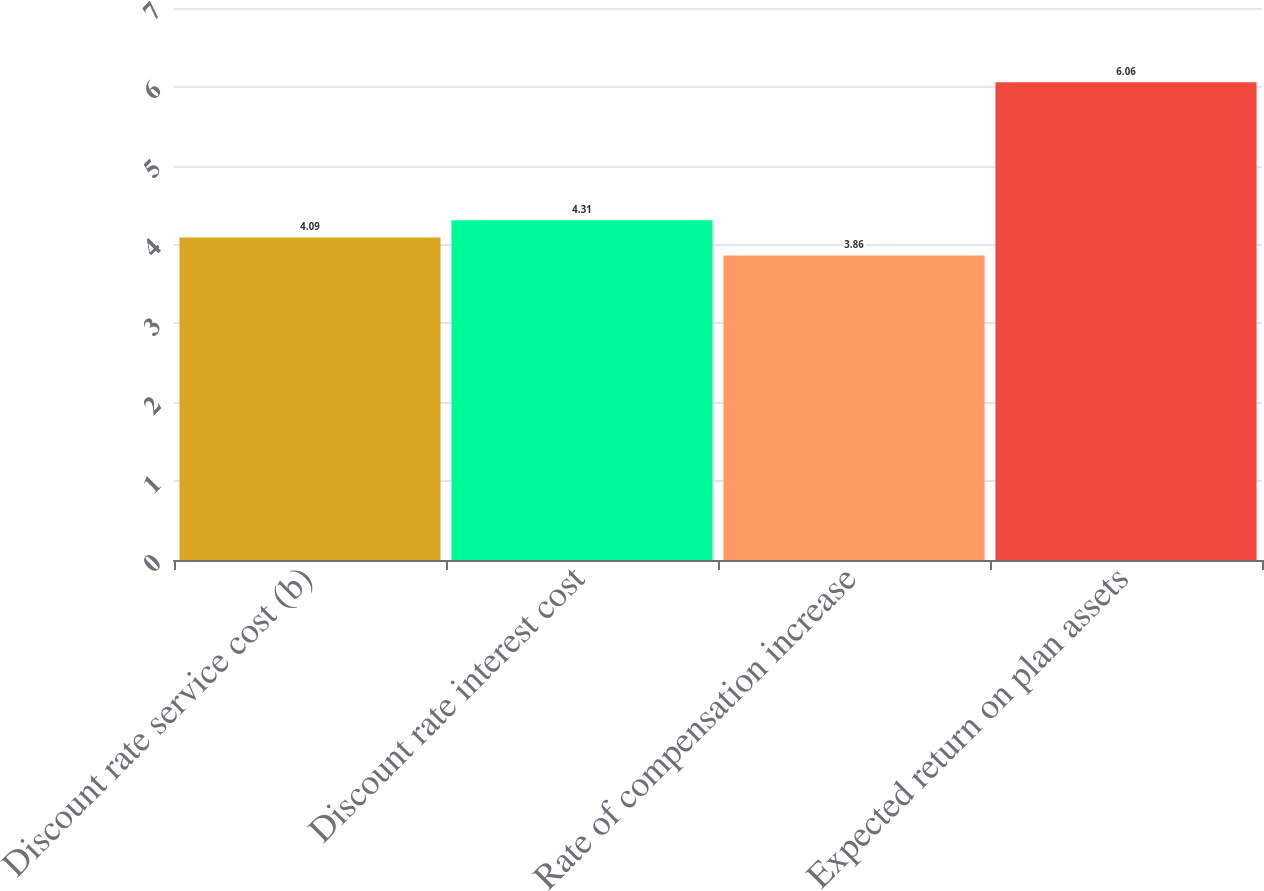Convert chart. <chart><loc_0><loc_0><loc_500><loc_500><bar_chart><fcel>Discount rate service cost (b)<fcel>Discount rate interest cost<fcel>Rate of compensation increase<fcel>Expected return on plan assets<nl><fcel>4.09<fcel>4.31<fcel>3.86<fcel>6.06<nl></chart> 